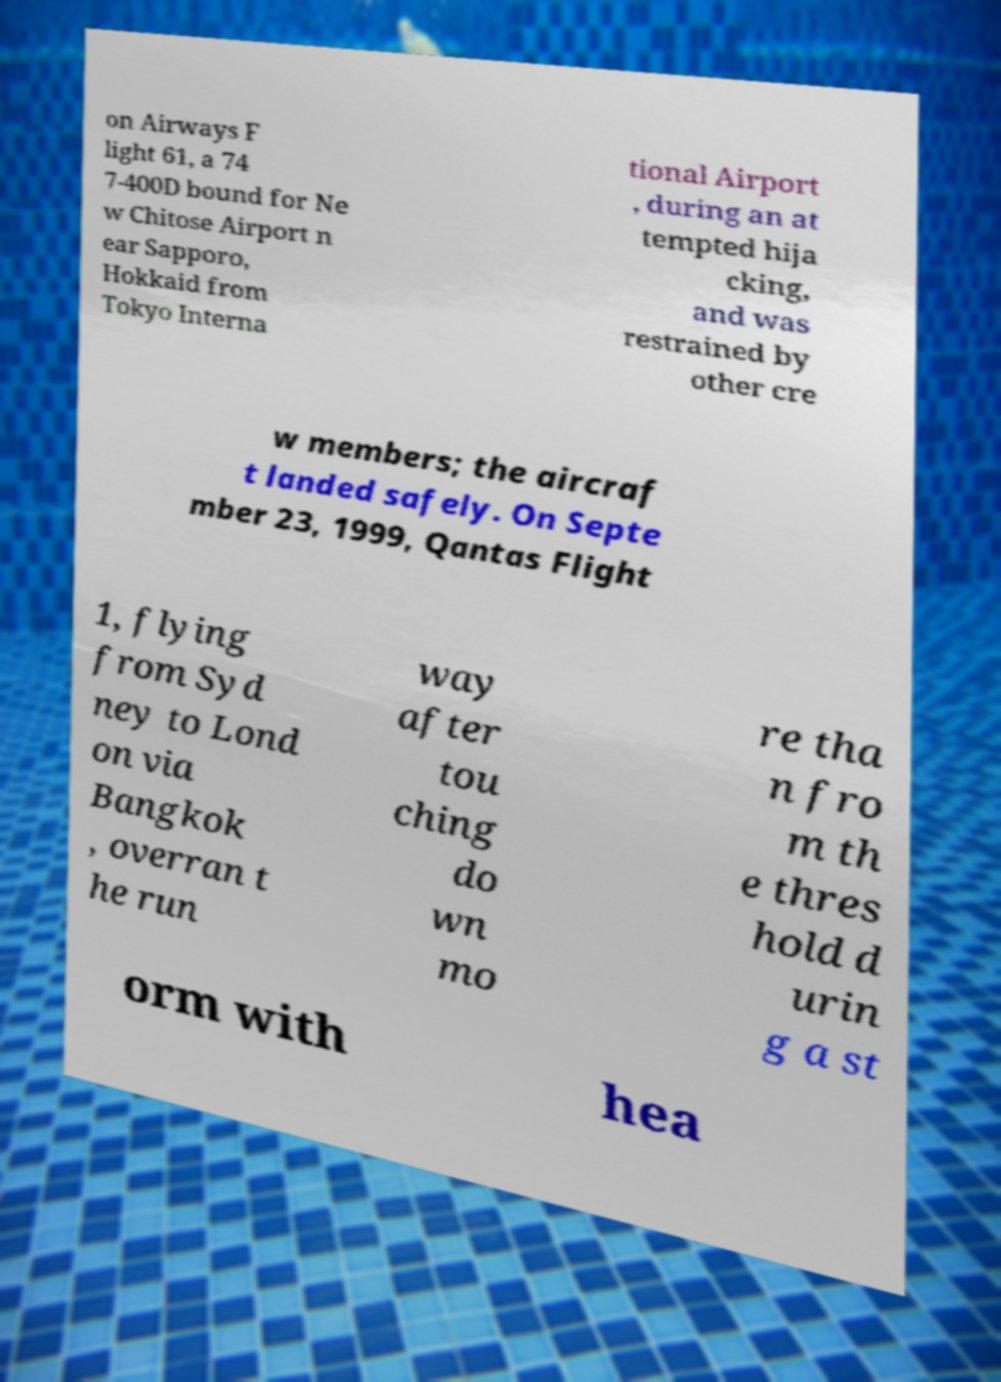There's text embedded in this image that I need extracted. Can you transcribe it verbatim? on Airways F light 61, a 74 7-400D bound for Ne w Chitose Airport n ear Sapporo, Hokkaid from Tokyo Interna tional Airport , during an at tempted hija cking, and was restrained by other cre w members; the aircraf t landed safely. On Septe mber 23, 1999, Qantas Flight 1, flying from Syd ney to Lond on via Bangkok , overran t he run way after tou ching do wn mo re tha n fro m th e thres hold d urin g a st orm with hea 